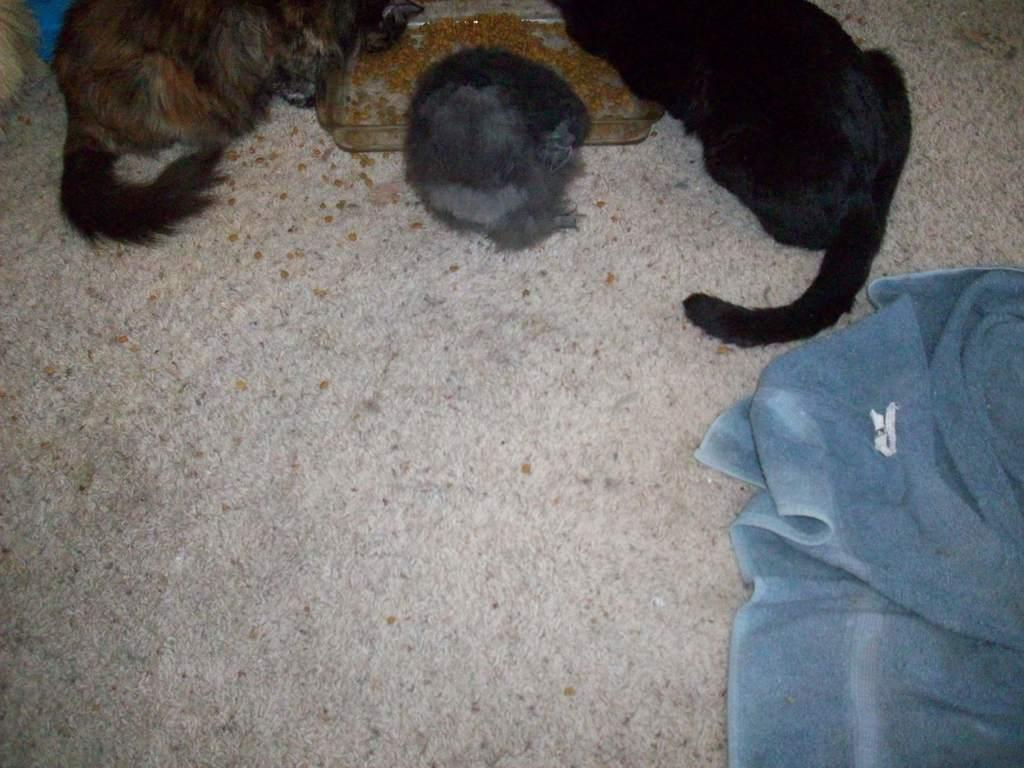What type of food item is in the square bowl in the image? The facts do not specify the type of food item in the square bowl. What animals are present in the image? There are animals in the image, but the facts do not specify which animals. What is the purpose of the blanket on the floor in the image? The facts do not specify the purpose of the blanket on the floor. Is there a spy observing the animals in the image? There is no mention of a spy or any spying activity in the image. 